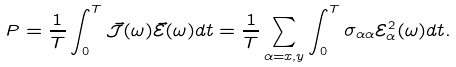<formula> <loc_0><loc_0><loc_500><loc_500>P = \frac { 1 } { T } \int _ { 0 } ^ { T } \vec { \mathcal { J } } ( \omega ) \vec { \mathcal { E } } ( \omega ) d t = \frac { 1 } { T } \sum _ { \alpha = x , y } \int _ { 0 } ^ { T } \sigma _ { \alpha \alpha } { \mathcal { E } } _ { \alpha } ^ { 2 } ( \omega ) d t .</formula> 